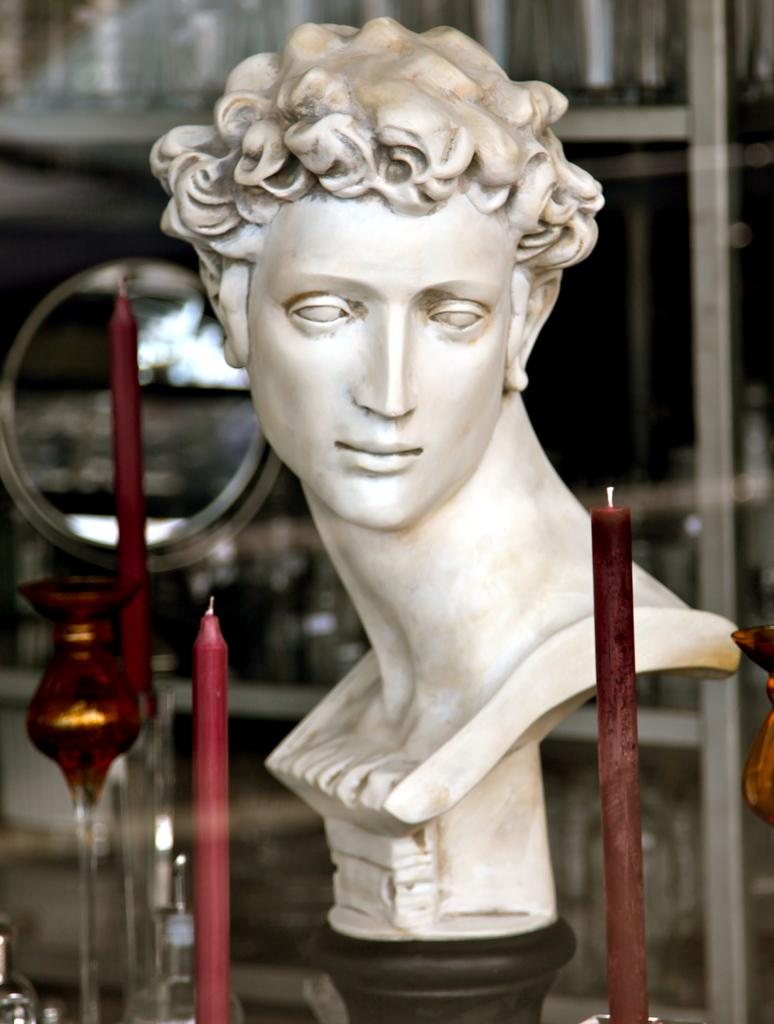What is the main subject of the image? There is a statue on a pedestal in the image. What objects are present near the statue? There are candles on candle holders in the image. What can be seen in the background of the image? There are grills visible in the background of the image. How does the statue defend itself from the attacking balloon in the image? There is no balloon or attack present in the image; the statue is simply on a pedestal with candles nearby. 